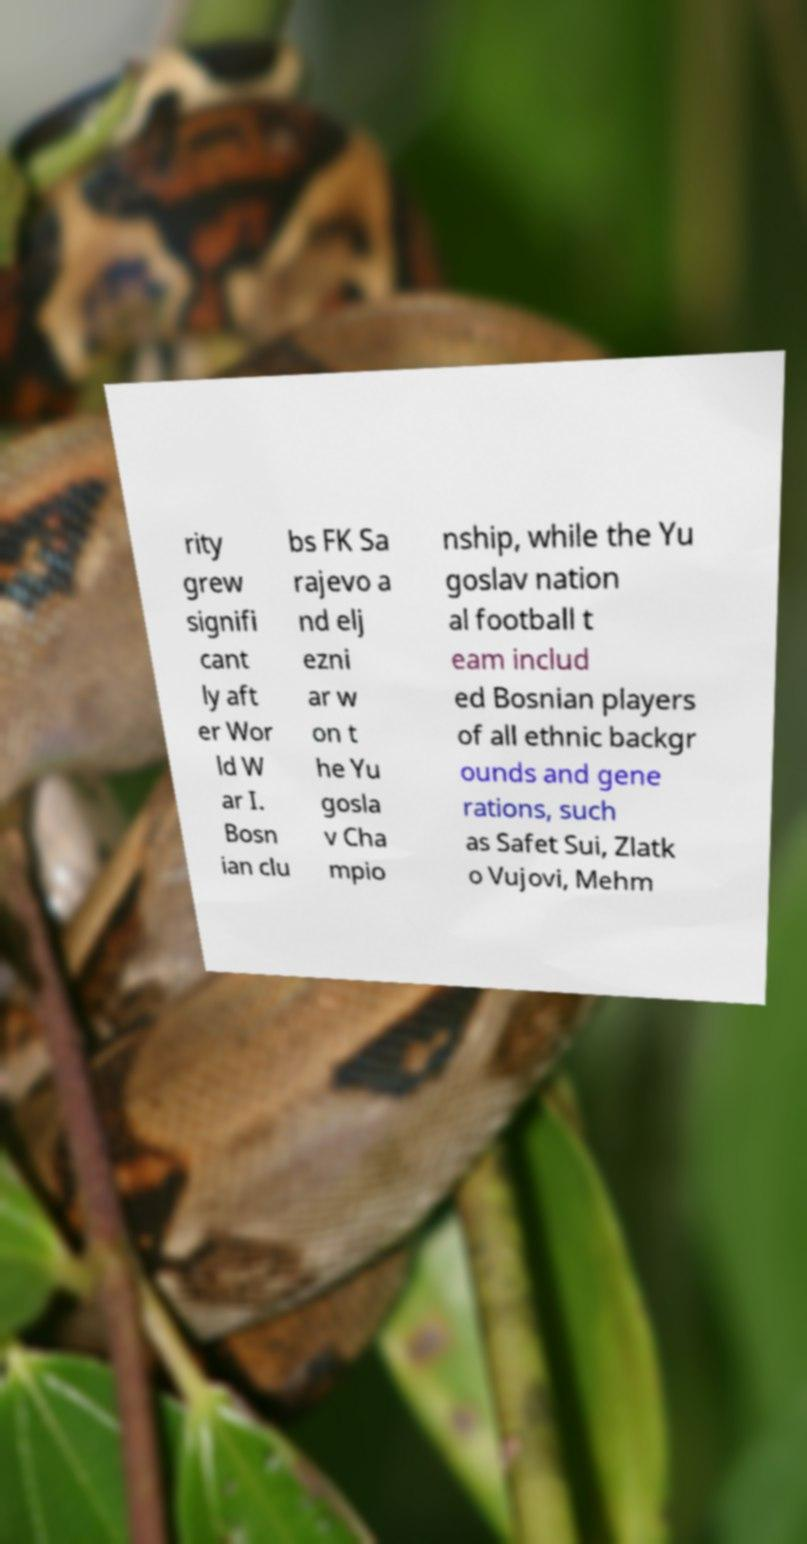Can you accurately transcribe the text from the provided image for me? rity grew signifi cant ly aft er Wor ld W ar I. Bosn ian clu bs FK Sa rajevo a nd elj ezni ar w on t he Yu gosla v Cha mpio nship, while the Yu goslav nation al football t eam includ ed Bosnian players of all ethnic backgr ounds and gene rations, such as Safet Sui, Zlatk o Vujovi, Mehm 